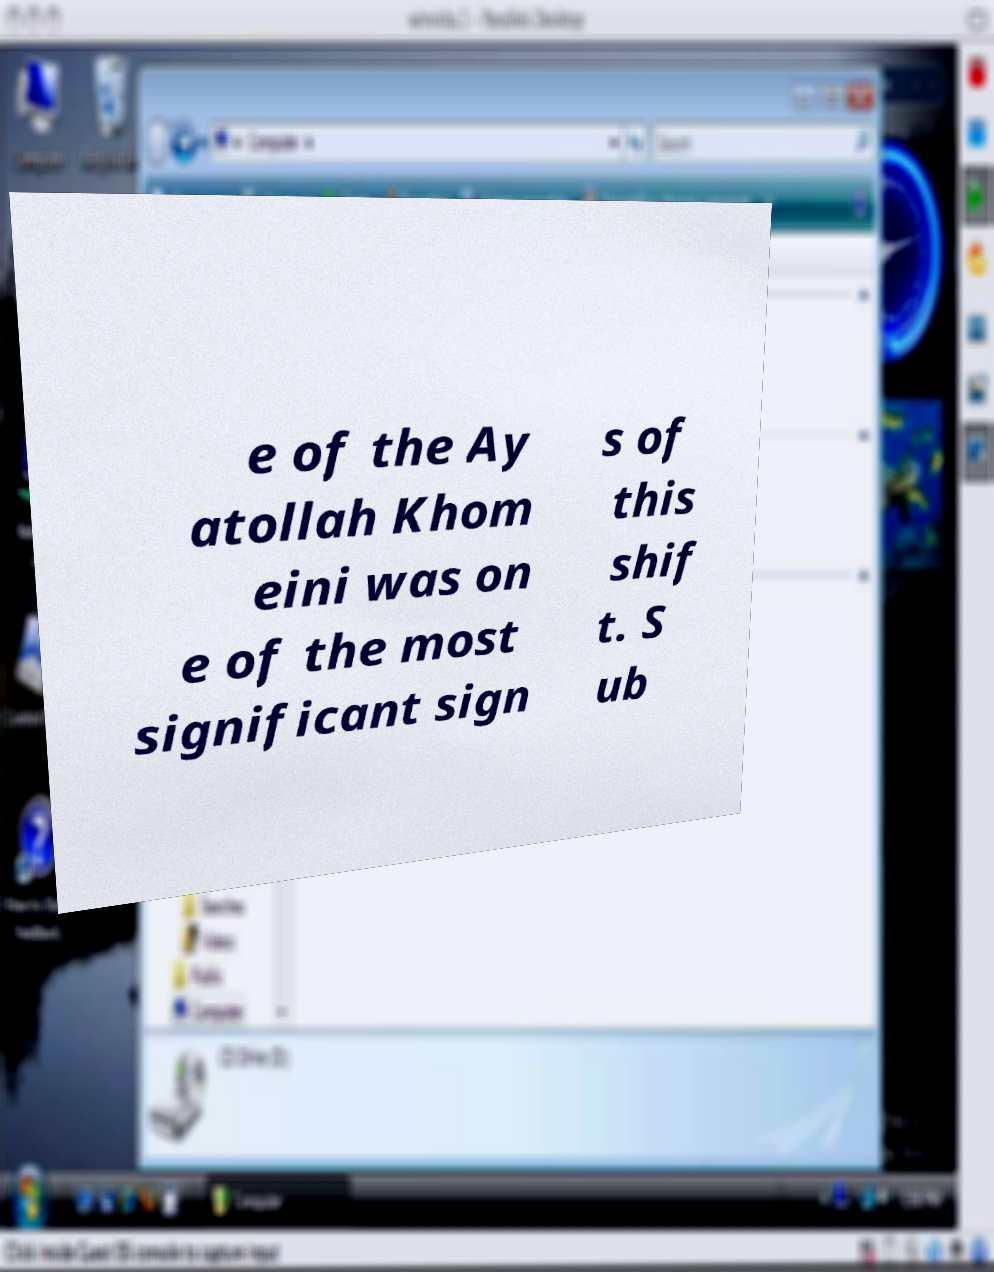For documentation purposes, I need the text within this image transcribed. Could you provide that? e of the Ay atollah Khom eini was on e of the most significant sign s of this shif t. S ub 